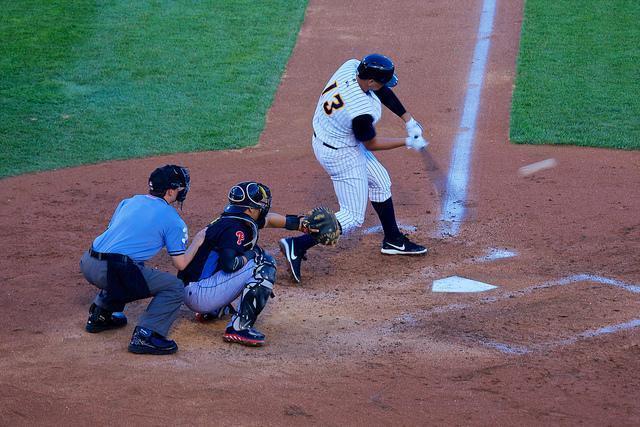How many people are in the picture?
Give a very brief answer. 3. How many bottles are there?
Give a very brief answer. 0. 